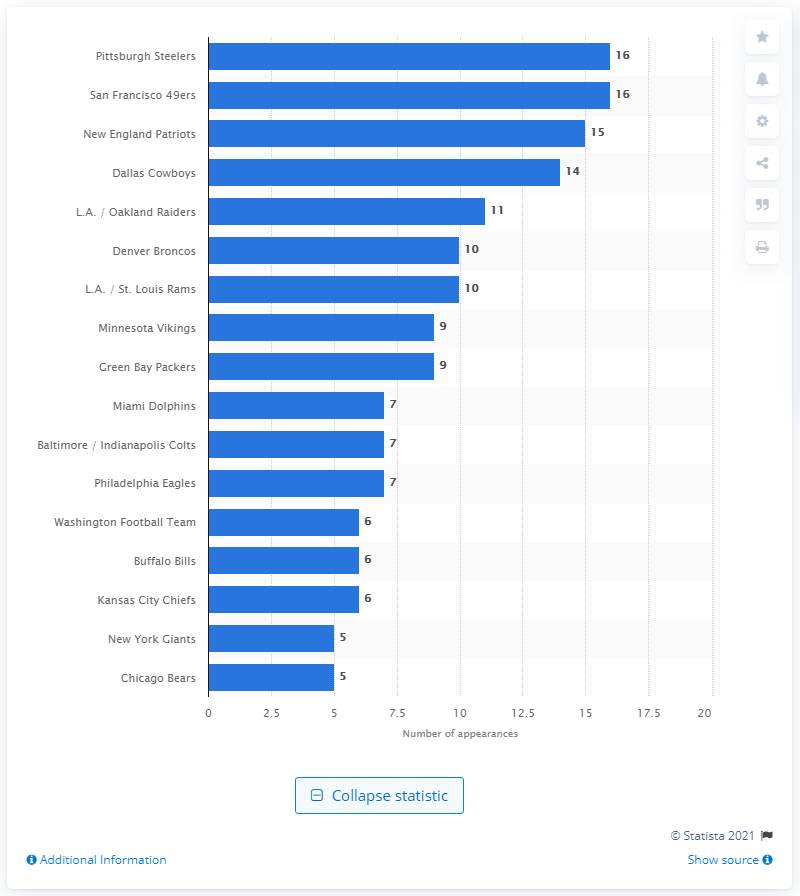Give some essential details in this illustration. The New England Patriots have the most wins of all NFL teams. 